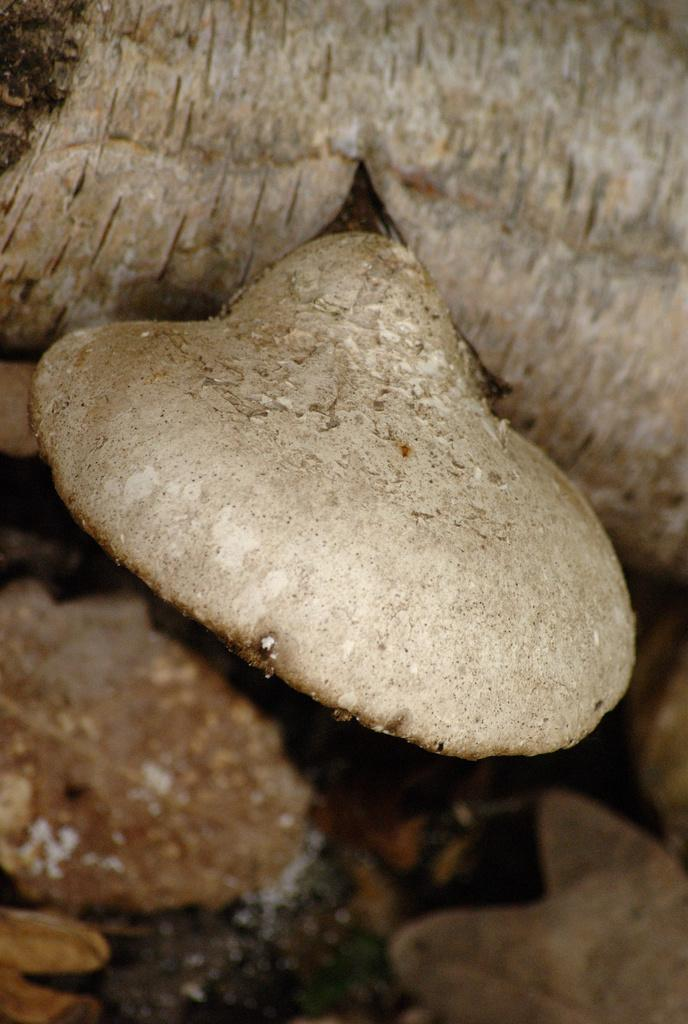What is the focus of the image? The image is zoomed in, with the focus on objects in the center. What are the objects in the center of the image? The objects appear to be stones. How many lizards can be seen crawling on the stones in the image? There are no lizards present in the image; it only features stones. Can you provide an example of a similar image with different objects? The provided facts only describe the current image, so it's not possible to provide an example of a similar image with different objects. 